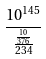<formula> <loc_0><loc_0><loc_500><loc_500>\frac { 1 0 ^ { 1 4 5 } } { \frac { \frac { 1 0 } { 3 7 6 } } { 2 3 4 } }</formula> 